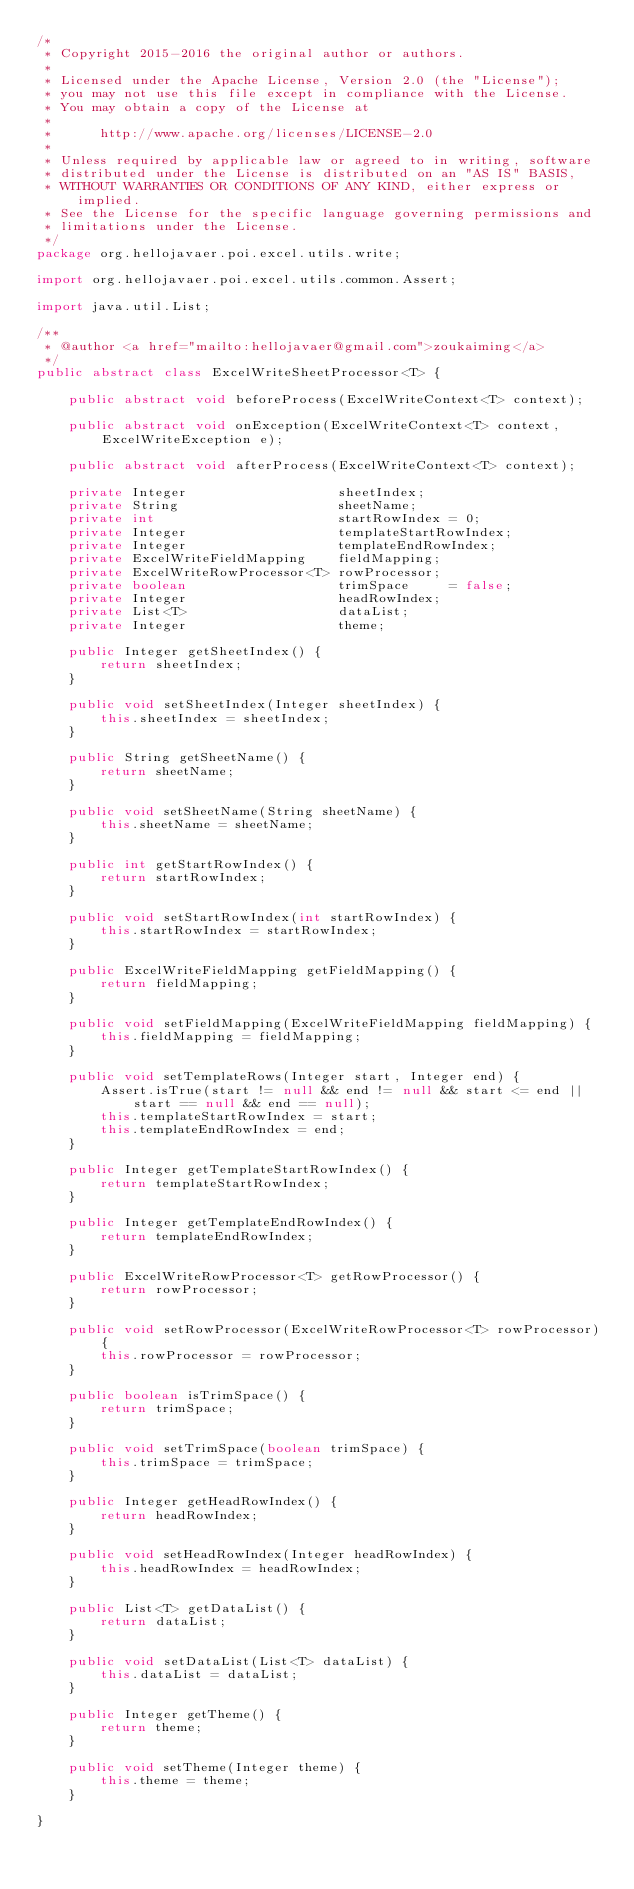Convert code to text. <code><loc_0><loc_0><loc_500><loc_500><_Java_>/*
 * Copyright 2015-2016 the original author or authors.
 *
 * Licensed under the Apache License, Version 2.0 (the "License");
 * you may not use this file except in compliance with the License.
 * You may obtain a copy of the License at
 *
 *      http://www.apache.org/licenses/LICENSE-2.0
 *
 * Unless required by applicable law or agreed to in writing, software
 * distributed under the License is distributed on an "AS IS" BASIS,
 * WITHOUT WARRANTIES OR CONDITIONS OF ANY KIND, either express or implied.
 * See the License for the specific language governing permissions and
 * limitations under the License.
 */
package org.hellojavaer.poi.excel.utils.write;

import org.hellojavaer.poi.excel.utils.common.Assert;

import java.util.List;

/**
 * @author <a href="mailto:hellojavaer@gmail.com">zoukaiming</a>
 */
public abstract class ExcelWriteSheetProcessor<T> {

    public abstract void beforeProcess(ExcelWriteContext<T> context);

    public abstract void onException(ExcelWriteContext<T> context, ExcelWriteException e);

    public abstract void afterProcess(ExcelWriteContext<T> context);

    private Integer                   sheetIndex;
    private String                    sheetName;
    private int                       startRowIndex = 0;
    private Integer                   templateStartRowIndex;
    private Integer                   templateEndRowIndex;
    private ExcelWriteFieldMapping    fieldMapping;
    private ExcelWriteRowProcessor<T> rowProcessor;
    private boolean                   trimSpace     = false;
    private Integer                   headRowIndex;
    private List<T>                   dataList;
    private Integer                   theme;

    public Integer getSheetIndex() {
        return sheetIndex;
    }

    public void setSheetIndex(Integer sheetIndex) {
        this.sheetIndex = sheetIndex;
    }

    public String getSheetName() {
        return sheetName;
    }

    public void setSheetName(String sheetName) {
        this.sheetName = sheetName;
    }

    public int getStartRowIndex() {
        return startRowIndex;
    }

    public void setStartRowIndex(int startRowIndex) {
        this.startRowIndex = startRowIndex;
    }

    public ExcelWriteFieldMapping getFieldMapping() {
        return fieldMapping;
    }

    public void setFieldMapping(ExcelWriteFieldMapping fieldMapping) {
        this.fieldMapping = fieldMapping;
    }

    public void setTemplateRows(Integer start, Integer end) {
        Assert.isTrue(start != null && end != null && start <= end || start == null && end == null);
        this.templateStartRowIndex = start;
        this.templateEndRowIndex = end;
    }

    public Integer getTemplateStartRowIndex() {
        return templateStartRowIndex;
    }

    public Integer getTemplateEndRowIndex() {
        return templateEndRowIndex;
    }

    public ExcelWriteRowProcessor<T> getRowProcessor() {
        return rowProcessor;
    }

    public void setRowProcessor(ExcelWriteRowProcessor<T> rowProcessor) {
        this.rowProcessor = rowProcessor;
    }

    public boolean isTrimSpace() {
        return trimSpace;
    }

    public void setTrimSpace(boolean trimSpace) {
        this.trimSpace = trimSpace;
    }

    public Integer getHeadRowIndex() {
        return headRowIndex;
    }

    public void setHeadRowIndex(Integer headRowIndex) {
        this.headRowIndex = headRowIndex;
    }

    public List<T> getDataList() {
        return dataList;
    }

    public void setDataList(List<T> dataList) {
        this.dataList = dataList;
    }

    public Integer getTheme() {
        return theme;
    }

    public void setTheme(Integer theme) {
        this.theme = theme;
    }

}
</code> 